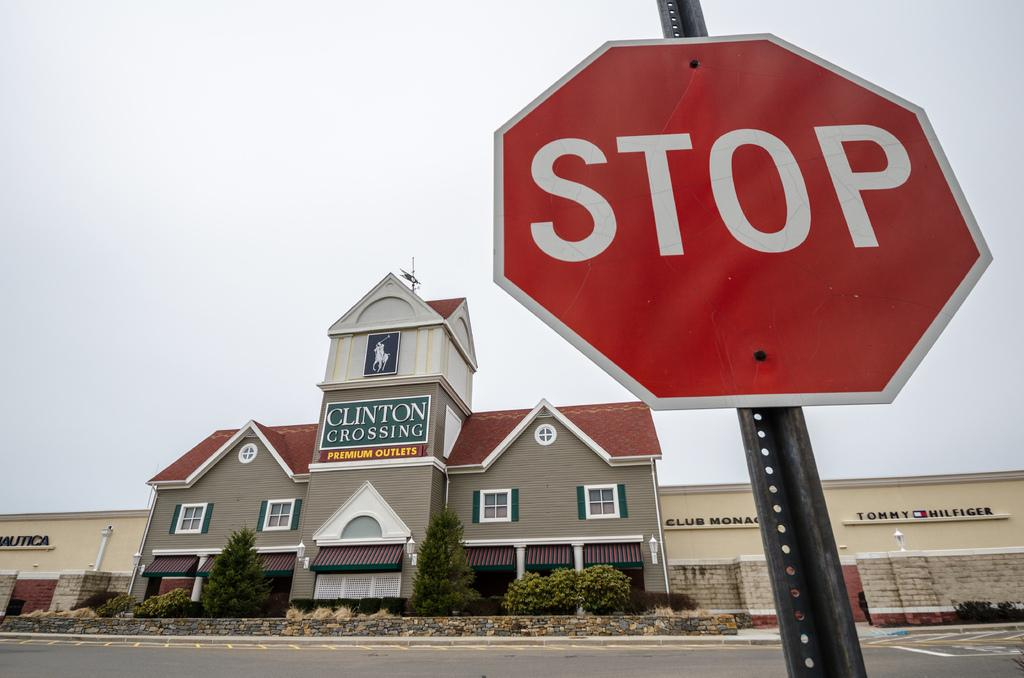<image>
Write a terse but informative summary of the picture. a Stop sign in front of a Clinton Crossing building 